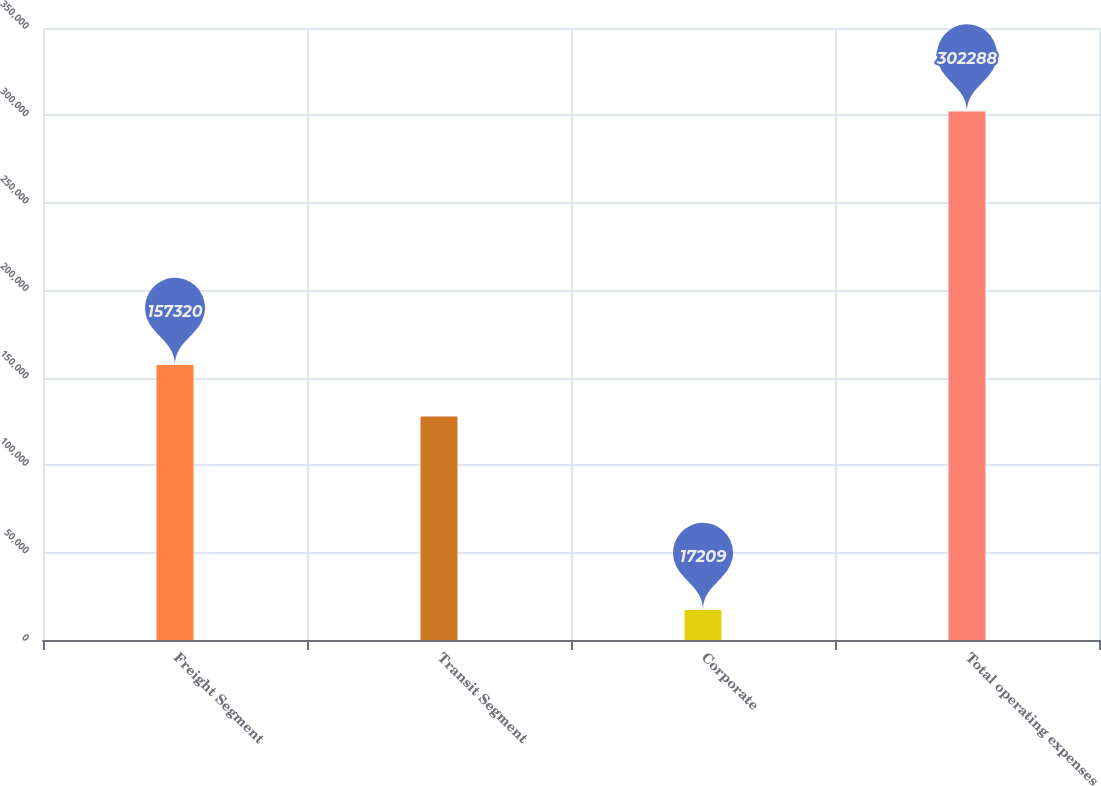Convert chart. <chart><loc_0><loc_0><loc_500><loc_500><bar_chart><fcel>Freight Segment<fcel>Transit Segment<fcel>Corporate<fcel>Total operating expenses<nl><fcel>157320<fcel>127759<fcel>17209<fcel>302288<nl></chart> 